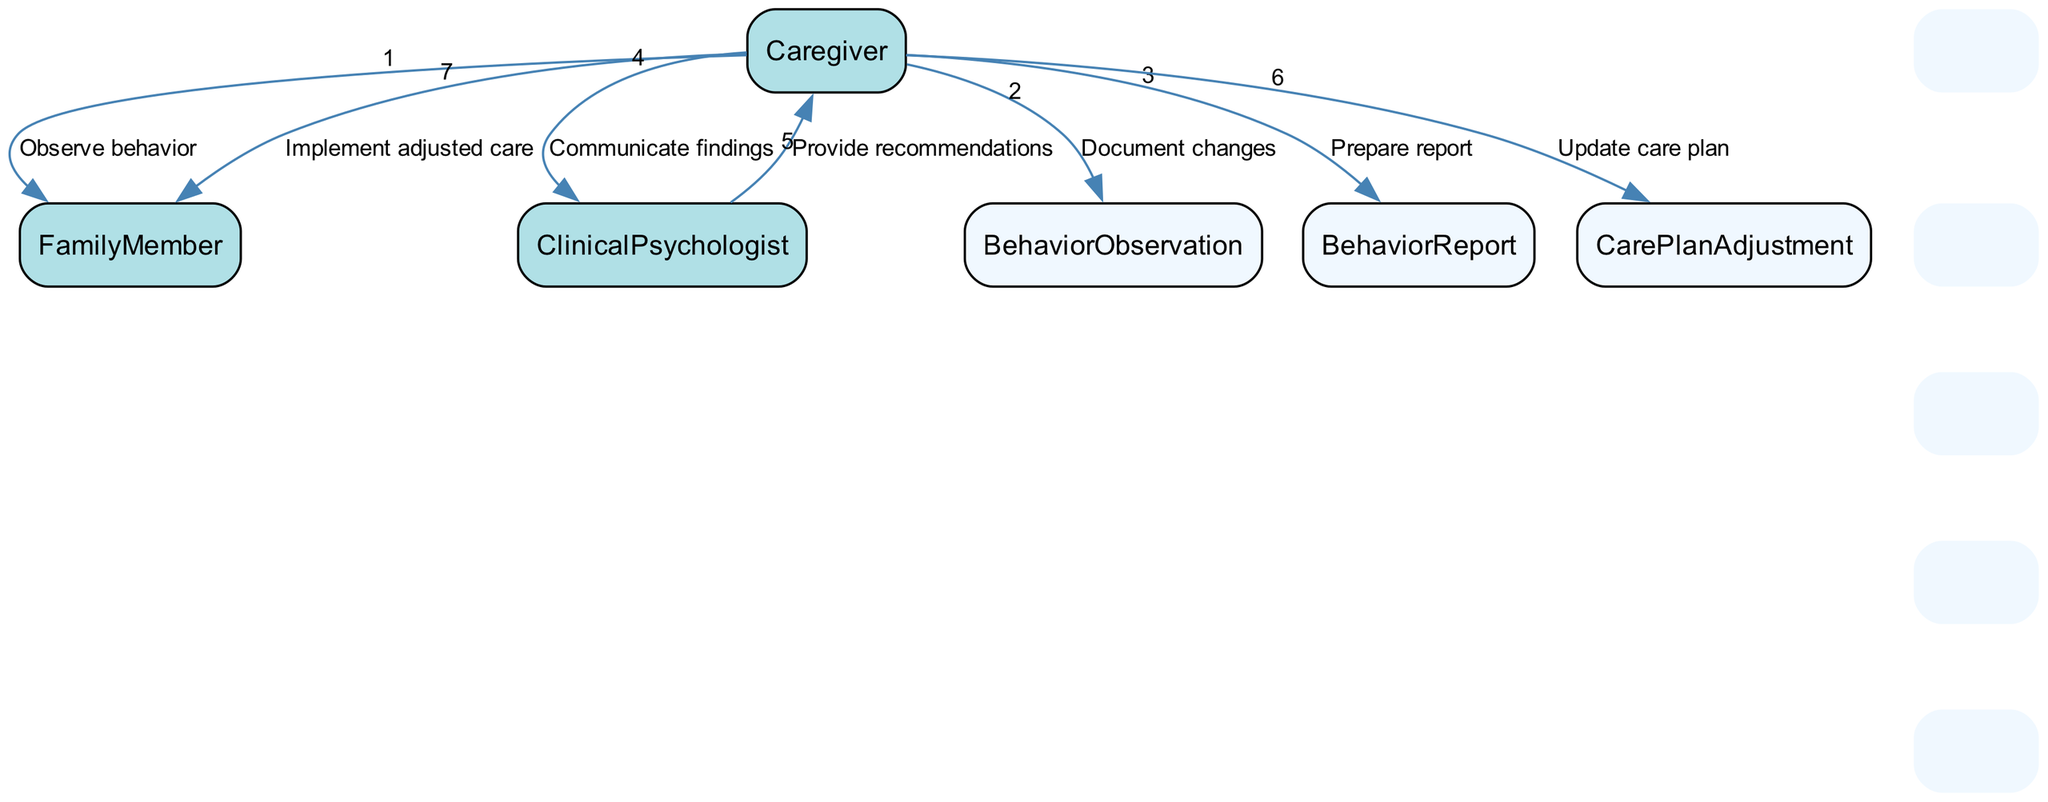What are the actors involved in the monitoring process? The diagram includes three actors: the caregiver, the family member, and the clinical psychologist. Each has distinct roles within the process.
Answer: caregiver, family member, clinical psychologist How many actions does the caregiver perform in the sequence? The caregiver performs four actions: observing behavior, documenting changes, preparing the report, and communicating findings. This enumeration is derived from analyzing the edges connected to the caregiver.
Answer: four What document does the caregiver prepare after observing behavior? The caregiver prepares a behavior report that includes documented behavioral changes observed in the family member during the monitoring process.
Answer: behavior report Which actor receives recommendations after communicating findings? The caregiver receives recommendations from the clinical psychologist after the caregiver communicates their findings. This can be traced through the flow of actions between the caregiver and the psychologist.
Answer: caregiver Which entity represents adjustments made by the caregiver? The care plan adjustment entity represents the updated care strategies made by the caregiver based on feedback from the clinical psychologist. It illustrates the caregiver's response to the recommendations provided.
Answer: care plan adjustment What comes immediately after the caregiver prepares the report? After the caregiver prepares the report, the next action is to communicate findings to the clinical psychologist, indicating a direct flow from report preparation to communication.
Answer: communicate findings How many total actions are depicted in the diagram? There are a total of seven actions outlined in the diagram, counted by analyzing each edge that represents an action within the sequence.
Answer: seven What is the last action taken by the caregiver? The last action taken by the caregiver, as represented in the diagram, is implementing adjusted care based on the refined care plan following feedback.
Answer: implement adjusted care What action precedes the update of the care plan? The action that precedes the update of the care plan is the communication of findings from the caregiver to the clinical psychologist, which leads to the psychologist providing recommendations for care adjustments.
Answer: communicate findings 